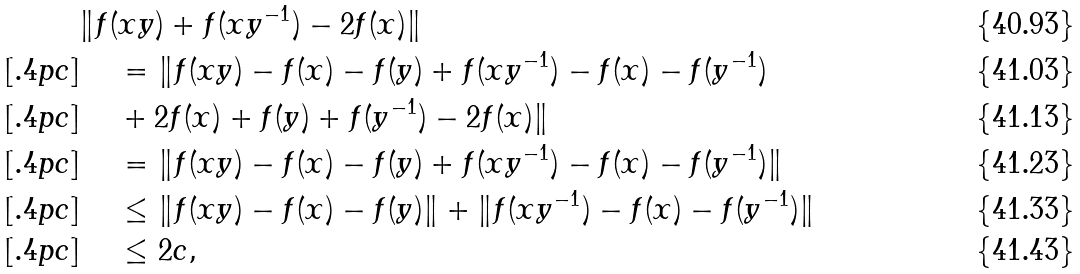Convert formula to latex. <formula><loc_0><loc_0><loc_500><loc_500>& \| f ( x y ) + f ( x y ^ { - 1 } ) - 2 f ( x ) \| \\ [ . 4 p c ] & \quad \, = \| f ( x y ) - f ( x ) - f ( y ) + f ( x y ^ { - 1 } ) - f ( x ) - f ( y ^ { - 1 } ) \\ [ . 4 p c ] & \quad \, + 2 f ( x ) + f ( y ) + f ( y ^ { - 1 } ) - 2 f ( x ) \| \\ [ . 4 p c ] & \quad \, = \| f ( x y ) - f ( x ) - f ( y ) + f ( x y ^ { - 1 } ) - f ( x ) - f ( y ^ { - 1 } ) \| \\ [ . 4 p c ] & \quad \, \leq \| f ( x y ) - f ( x ) - f ( y ) \| + \| f ( x y ^ { - 1 } ) - f ( x ) - f ( y ^ { - 1 } ) \| \\ [ . 4 p c ] & \quad \, \leq 2 c ,</formula> 